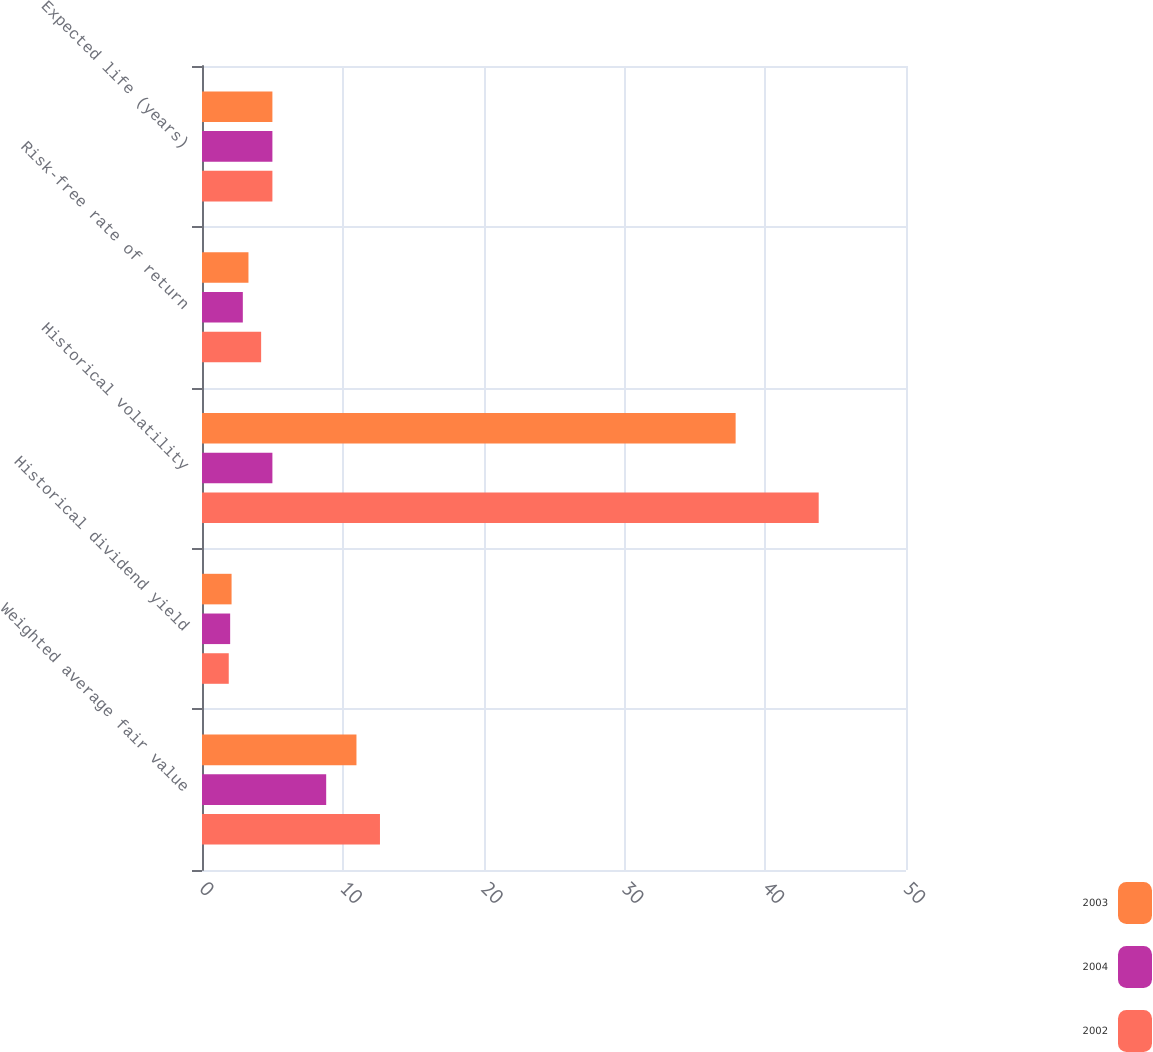Convert chart. <chart><loc_0><loc_0><loc_500><loc_500><stacked_bar_chart><ecel><fcel>Weighted average fair value<fcel>Historical dividend yield<fcel>Historical volatility<fcel>Risk-free rate of return<fcel>Expected life (years)<nl><fcel>2003<fcel>10.97<fcel>2.1<fcel>37.9<fcel>3.3<fcel>5<nl><fcel>2004<fcel>8.82<fcel>2<fcel>5<fcel>2.9<fcel>5<nl><fcel>2002<fcel>12.64<fcel>1.9<fcel>43.8<fcel>4.2<fcel>5<nl></chart> 